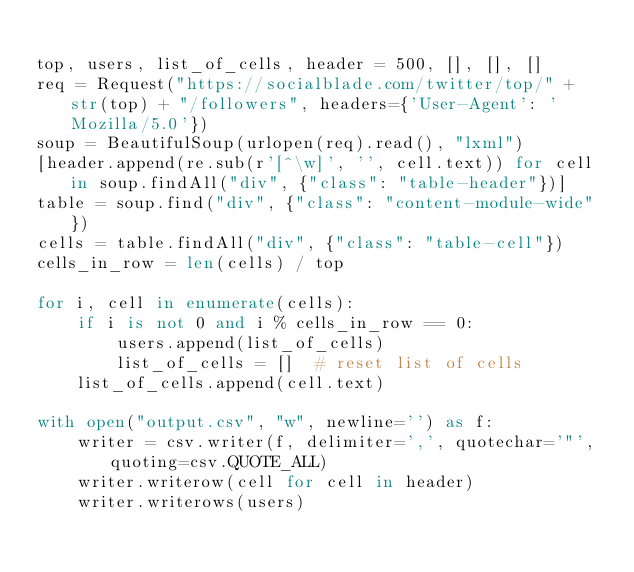<code> <loc_0><loc_0><loc_500><loc_500><_Python_>
top, users, list_of_cells, header = 500, [], [], []
req = Request("https://socialblade.com/twitter/top/" + str(top) + "/followers", headers={'User-Agent': 'Mozilla/5.0'})
soup = BeautifulSoup(urlopen(req).read(), "lxml")
[header.append(re.sub(r'[^\w]', '', cell.text)) for cell in soup.findAll("div", {"class": "table-header"})]
table = soup.find("div", {"class": "content-module-wide"})
cells = table.findAll("div", {"class": "table-cell"})
cells_in_row = len(cells) / top

for i, cell in enumerate(cells):
    if i is not 0 and i % cells_in_row == 0:
        users.append(list_of_cells)
        list_of_cells = []  # reset list of cells
    list_of_cells.append(cell.text)

with open("output.csv", "w", newline='') as f:
    writer = csv.writer(f, delimiter=',', quotechar='"', quoting=csv.QUOTE_ALL)
    writer.writerow(cell for cell in header)
    writer.writerows(users)
</code> 